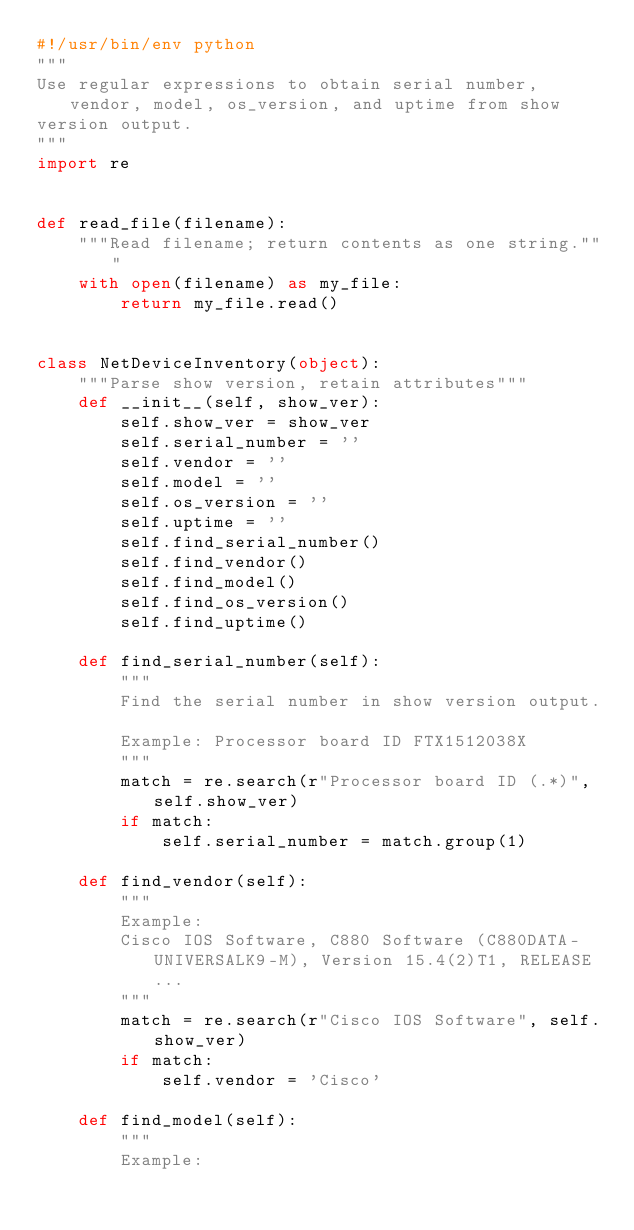<code> <loc_0><loc_0><loc_500><loc_500><_Python_>#!/usr/bin/env python
"""
Use regular expressions to obtain serial number, vendor, model, os_version, and uptime from show
version output.
"""
import re


def read_file(filename):
    """Read filename; return contents as one string."""
    with open(filename) as my_file:
        return my_file.read()


class NetDeviceInventory(object):
    """Parse show version, retain attributes"""
    def __init__(self, show_ver):
        self.show_ver = show_ver
        self.serial_number = ''
        self.vendor = ''
        self.model = ''
        self.os_version = ''
        self.uptime = ''
        self.find_serial_number()
        self.find_vendor()
        self.find_model()
        self.find_os_version()
        self.find_uptime()

    def find_serial_number(self):
        """
        Find the serial number in show version output.

        Example: Processor board ID FTX1512038X
        """
        match = re.search(r"Processor board ID (.*)", self.show_ver)
        if match:
            self.serial_number = match.group(1)

    def find_vendor(self):
        """
        Example:
        Cisco IOS Software, C880 Software (C880DATA-UNIVERSALK9-M), Version 15.4(2)T1, RELEASE...
        """
        match = re.search(r"Cisco IOS Software", self.show_ver)
        if match:
            self.vendor = 'Cisco'

    def find_model(self):
        """
        Example:</code> 